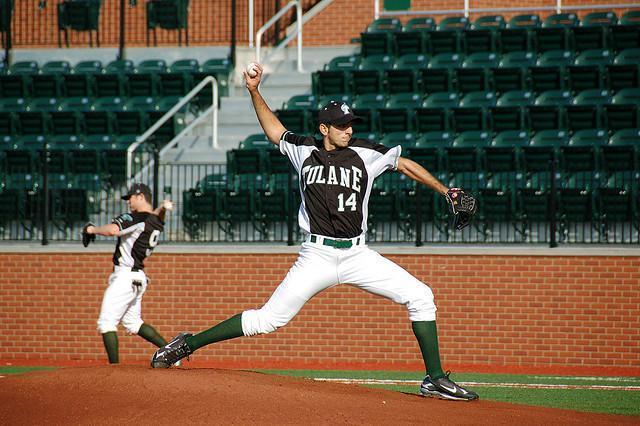How many people are in the picture?
Give a very brief answer. 2. 